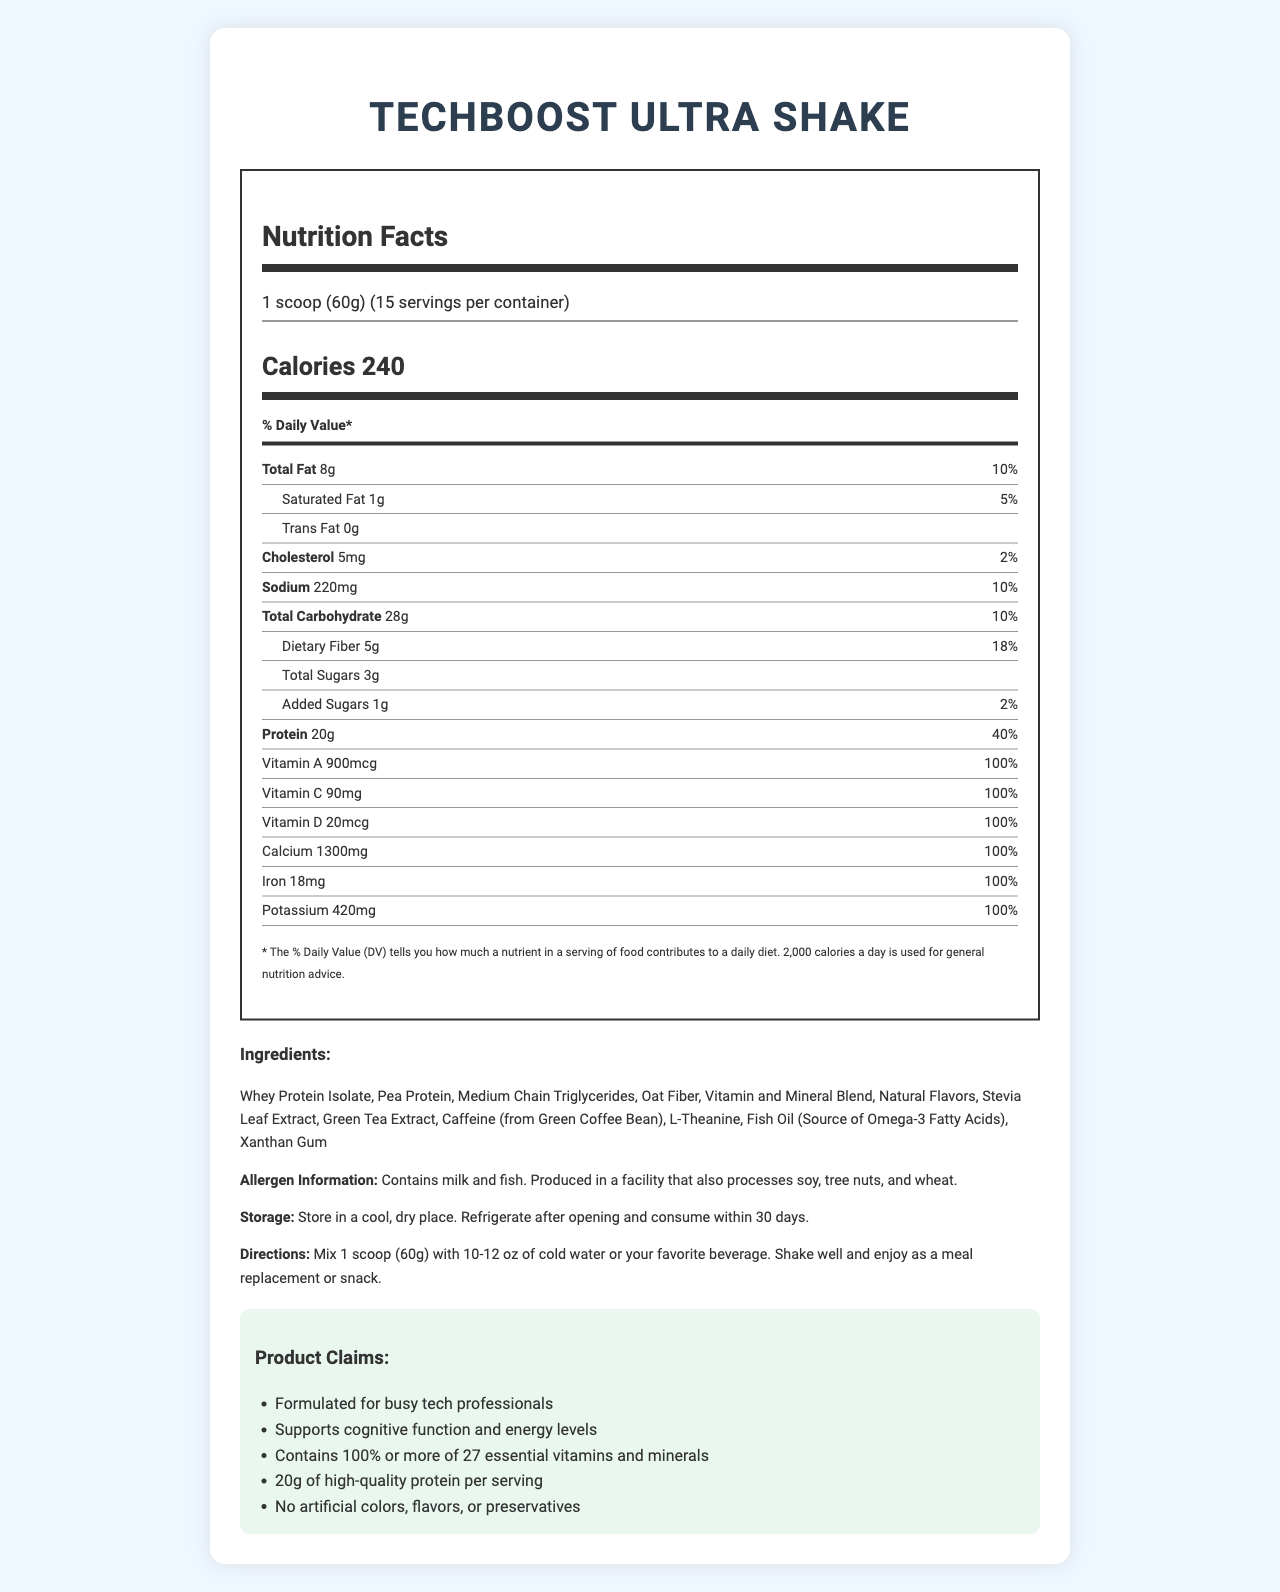what is the total fat per serving? The document clearly shows that the total fat per serving is 8g.
Answer: 8g how many milligrams of sodium does one serving contain? The document specifies the sodium content per serving as 220mg.
Answer: 220mg what is the serving size of TechBoost Ultra Shake? The serving size is indicated as 1 scoop (60g) on the label.
Answer: 1 scoop (60g) what percentage of the daily value for dietary fiber is in one serving? The daily value percentage for dietary fiber listed on the label is 18%.
Answer: 18% what is the caffeine content per serving? The caffeine content per serving, as mentioned in the ingredients list, is 100mg.
Answer: 100mg how many servings are in one container? A. 10 B. 15 C. 20 D. 25 According to the document, each container holds 15 servings.
Answer: B which ingredient is used as a source of omega-3 fatty acids? A. Pea Protein B. Green Tea Extract C. Fish Oil D. Oat Fiber The ingredients list shows that Fish Oil is the source of omega-3 fatty acids.
Answer: C is there any trans fat in the TechBoost Ultra Shake? The label indicates that there is 0g of trans fat in the shake.
Answer: No describe the main idea of the nutritional document The explanation is a brief description of all the components detailed in the nutrition facts document, summarizing product details, nutrition content, and various claims made by the product.
Answer: The document provides nutrition information about the TechBoost Ultra Shake, a meal replacement shake designed for busy tech professionals. It includes details about serving size, nutrient content, ingredients, allergen information, and claims such as supporting cognitive function and providing 100% or more of 27 essential vitamins and minerals. It also outlines preparation directions and storage instructions. what is the iron content in one serving? The document shows that one serving contains 18mg of iron.
Answer: 18mg how many claim statements are mentioned in the document? The claim statements section lists five individual claims about the product.
Answer: 5 does the product claim to support cognitive function and energy levels? One of the claim statements explicitly mentions supporting cognitive function and energy levels.
Answer: Yes what is the total carbohydrate content? The document states that the total carbohydrate content per serving is 28g.
Answer: 28g is "Medium Chain Triglycerides" listed as an ingredient? The ingredient list includes "Medium Chain Triglycerides".
Answer: Yes which vitamin is present at an amount of 30mcg per serving? A. Vitamin K B. Biotin C. Vitamin B12 D. Selenium The document lists Biotin with a content of 30mcg per serving.
Answer: B how much time does it take to prepare the shake? The document provides mixing instructions but does not specify the exact time required to prepare the shake.
Answer: Cannot be determined 